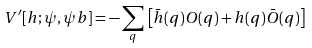<formula> <loc_0><loc_0><loc_500><loc_500>V ^ { \prime } [ h ; \psi , \psi b ] = - \sum _ { q } \, \left [ { \bar { h } } ( q ) O ( q ) + h ( q ) { \bar { O } } ( q ) \right ]</formula> 